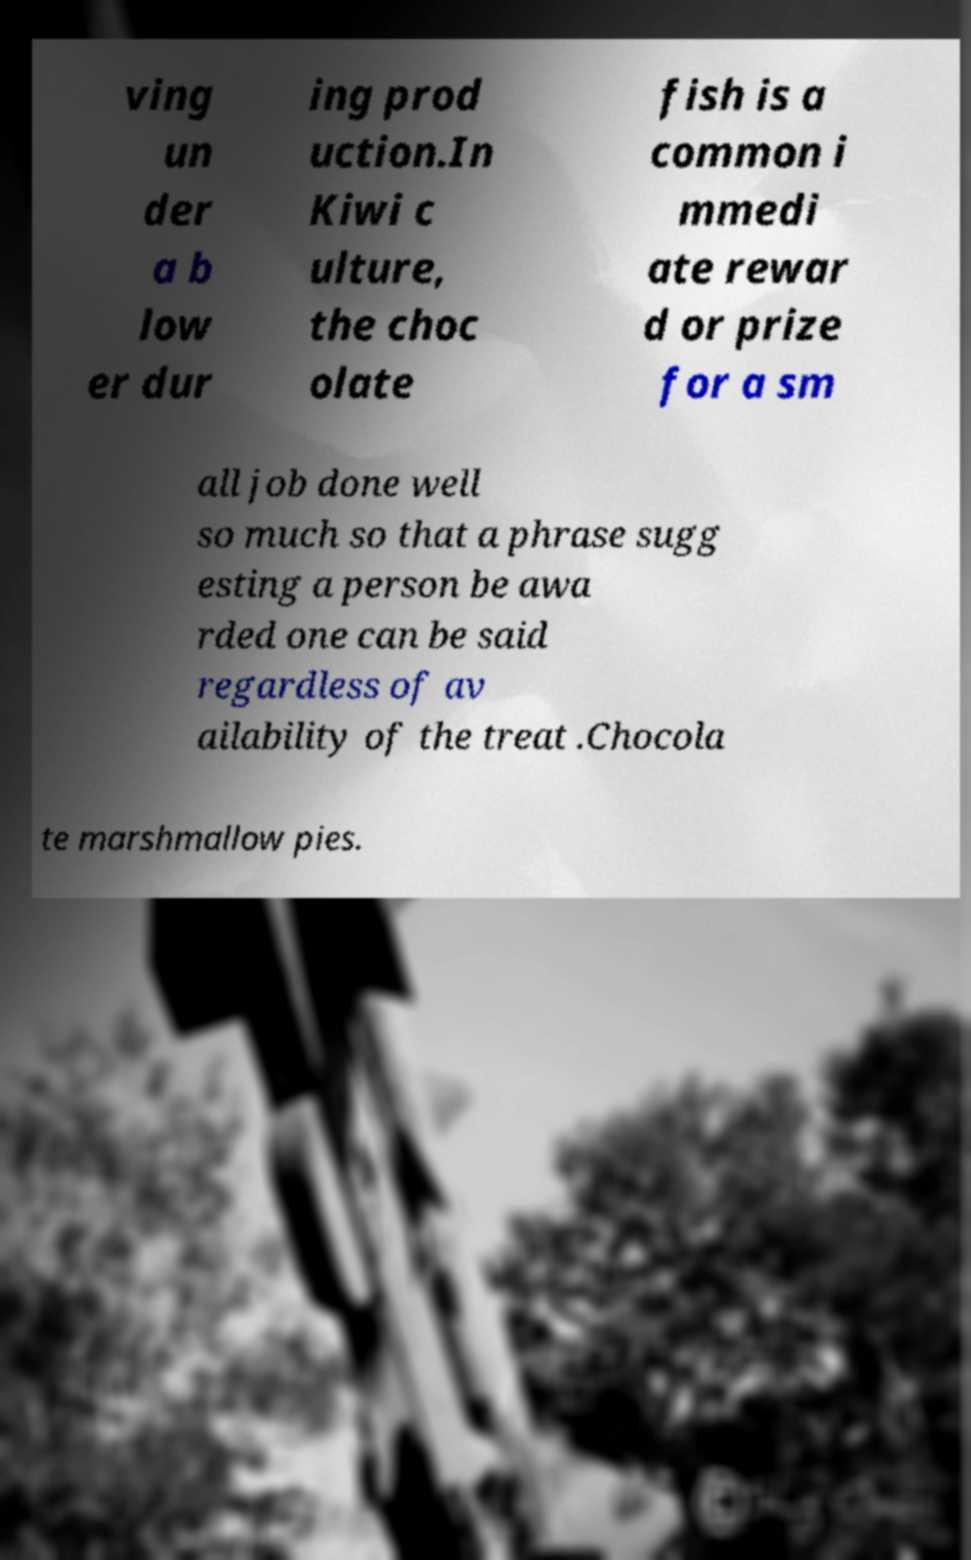For documentation purposes, I need the text within this image transcribed. Could you provide that? ving un der a b low er dur ing prod uction.In Kiwi c ulture, the choc olate fish is a common i mmedi ate rewar d or prize for a sm all job done well so much so that a phrase sugg esting a person be awa rded one can be said regardless of av ailability of the treat .Chocola te marshmallow pies. 